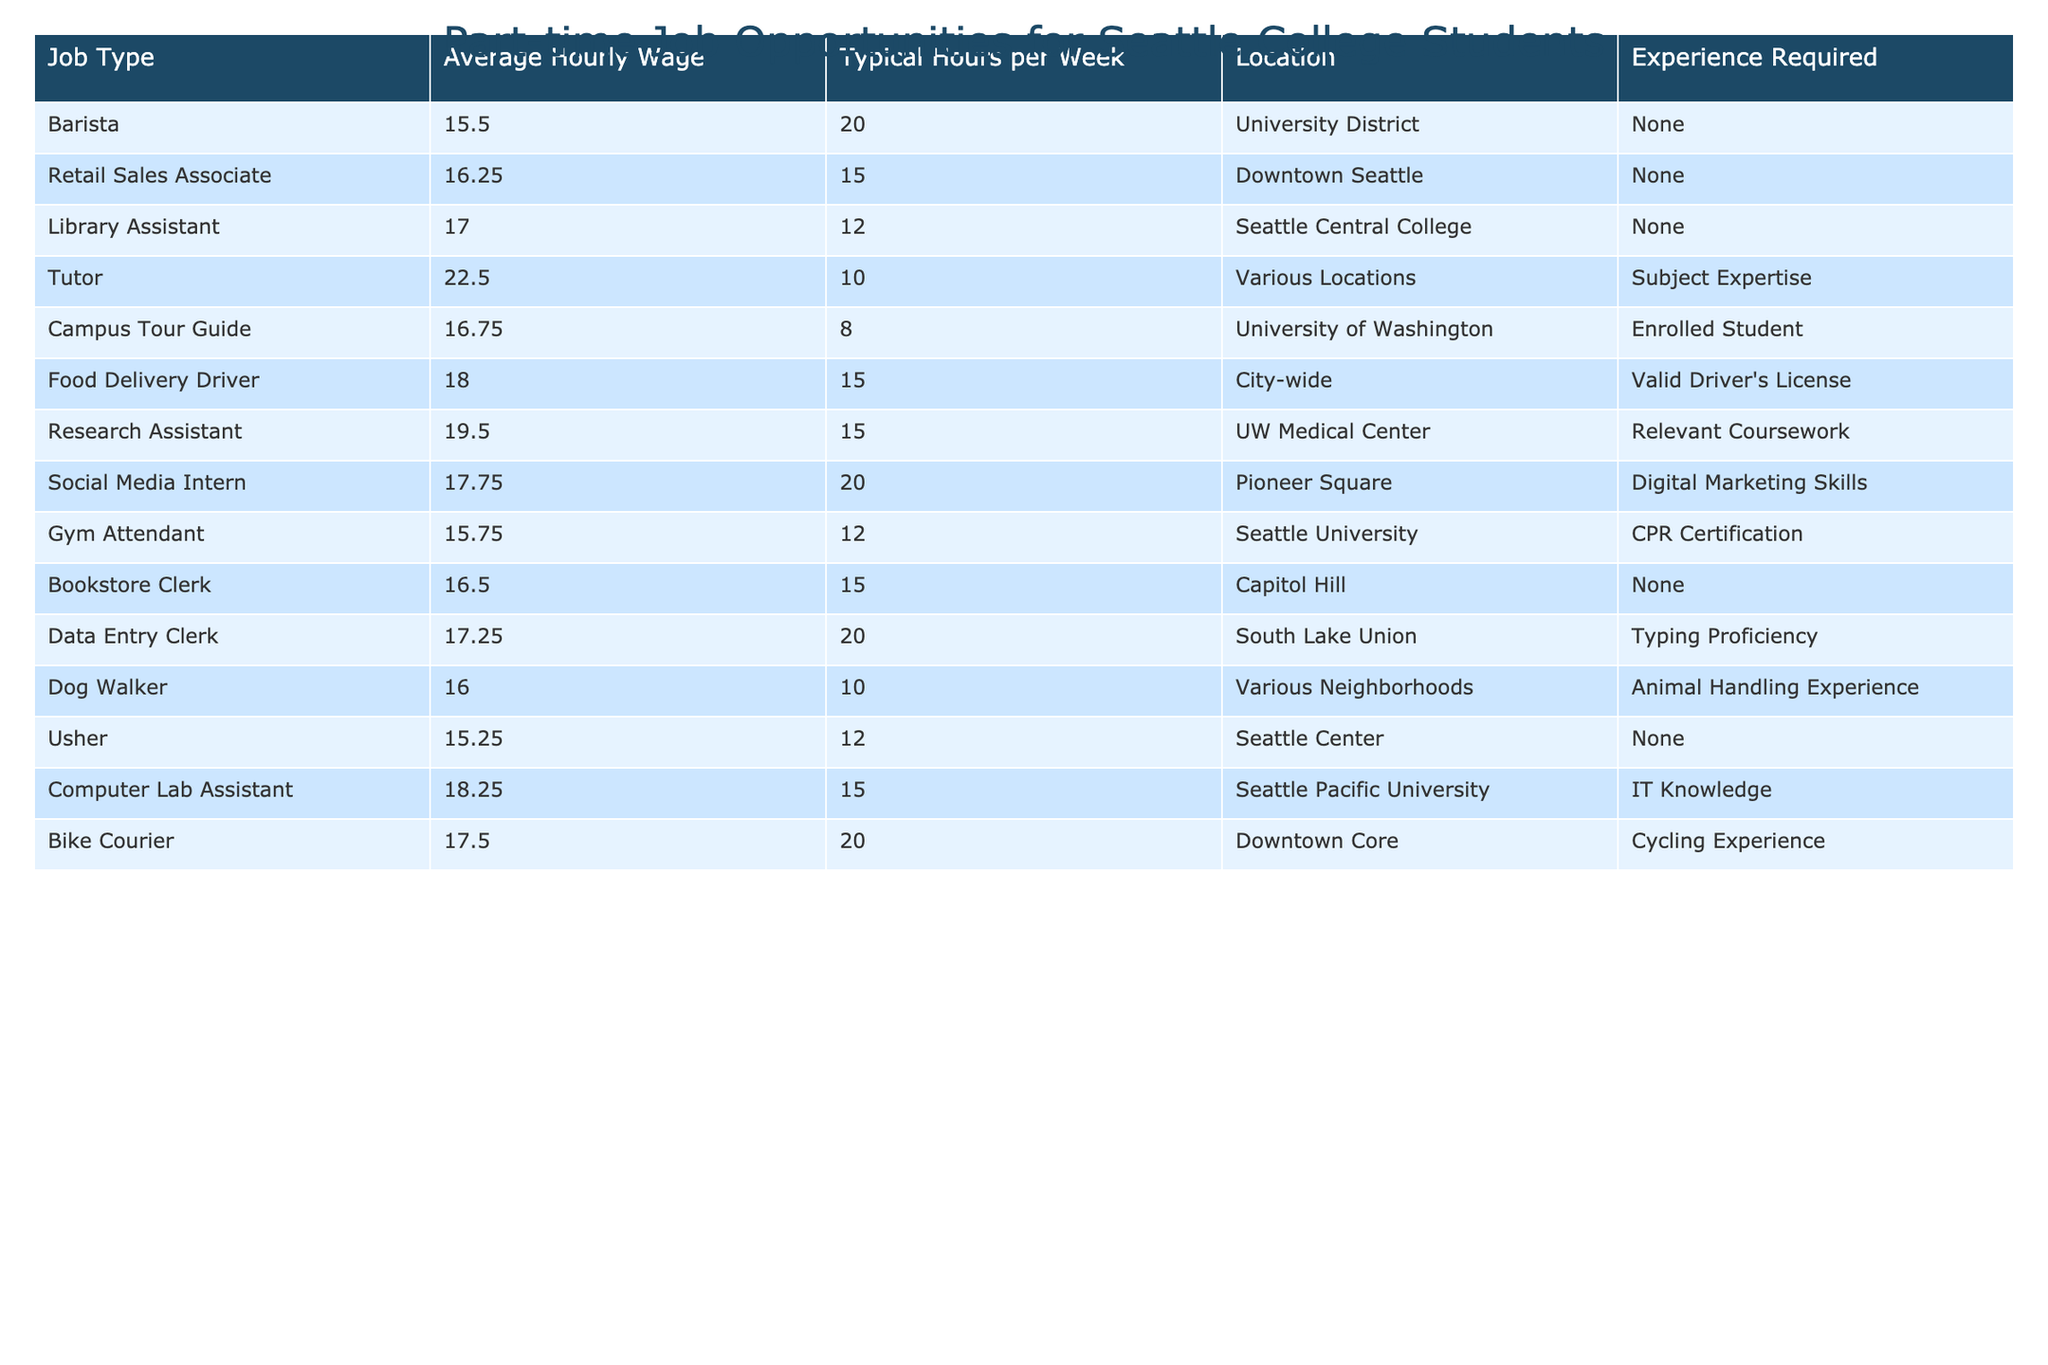What is the average hourly wage for a Barista? The table shows that the average hourly wage for a Barista is listed directly, which is $15.50.
Answer: $15.50 Which job offers the highest hourly wage? By comparing the average hourly wages for all job types in the table, the Tutor offers the highest wage at $22.50.
Answer: $22.50 How many hours per week does a Library Assistant typically work? The table indicates that a Library Assistant typically works 12 hours per week.
Answer: 12 hours True or False: A Food Delivery Driver requires prior experience to apply for the job. The table states that a Food Delivery Driver requires a valid driver's license but does not mention prior experience, making this statement False.
Answer: False What is the total number of hours worked per week for a Social Media Intern and a Campus Tour Guide combined? The Social Media Intern typically works 20 hours per week, and the Campus Tour Guide works 8 hours per week. Adding these together gives 20 + 8 = 28 hours.
Answer: 28 hours Which job requires the most experience? The Research Assistant position requires relevant coursework which is a form of experience, while most other jobs listed do not require any experience. Hence, Research Assistant requires the most level of expertise compared to the others.
Answer: Research Assistant Calculate the average hourly wage for all jobs that pay above $17.00. The jobs above $17.00 are Research Assistant ($19.50), Tutor ($22.50), and Computer Lab Assistant ($18.25), totaling $60.25. There are 3 jobs, so the average is $60.25 / 3 = $20.08.
Answer: $20.08 How many jobs listed do not require any experience? By reviewing the table, the jobs that do not require any experience are Barista, Retail Sales Associate, Usher, and Bookstore Clerk, making a total of 4 jobs.
Answer: 4 jobs Which job has the lowest average hourly wage, and what is that wage? From the data, the Usher position has the lowest average hourly wage of $15.25.
Answer: $15.25 If a student works as a Tutor for 10 weeks at the average hourly wage, how much will they earn? The average hourly wage for a Tutor is $22.50, and if they work 10 hours per week for 10 weeks, the total earnings will be 22.50 * 10 * 10 = $2250.
Answer: $2250 